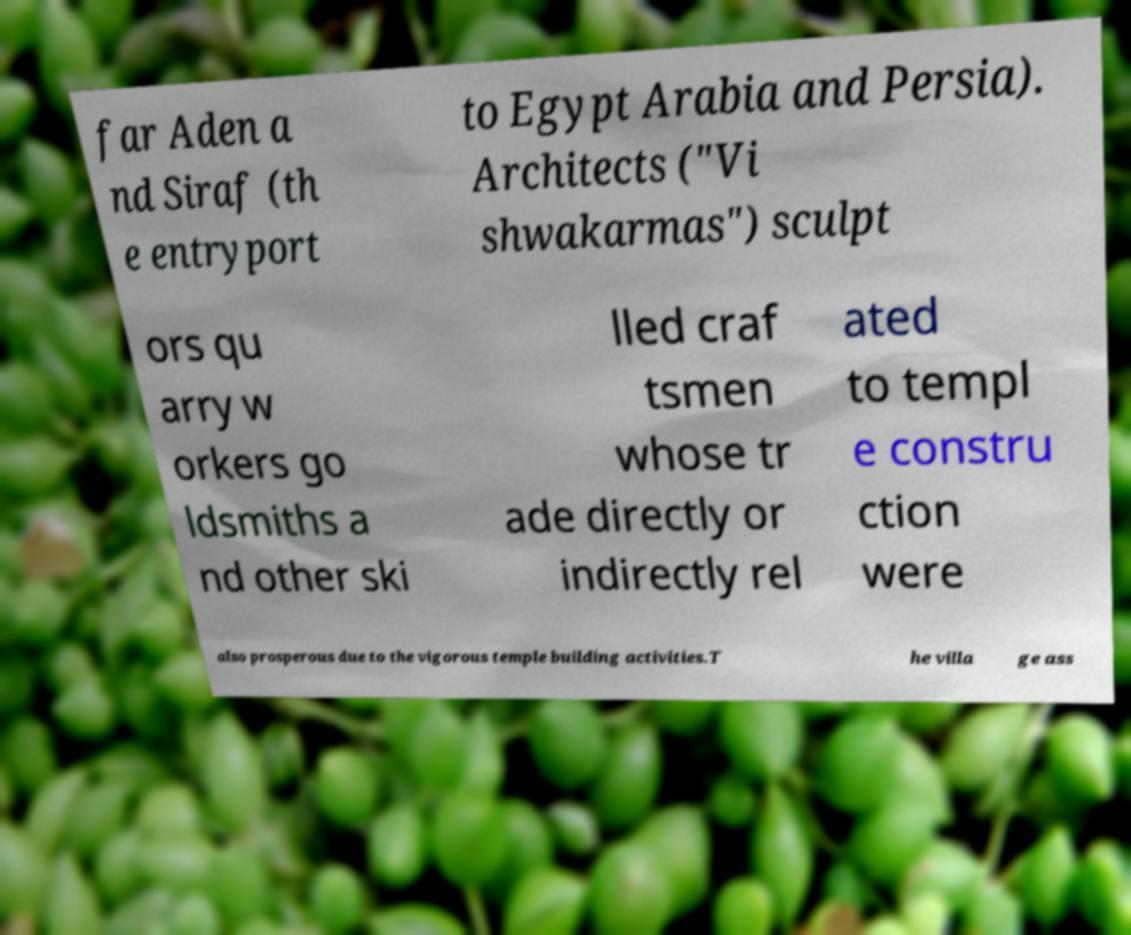Could you assist in decoding the text presented in this image and type it out clearly? far Aden a nd Siraf (th e entryport to Egypt Arabia and Persia). Architects ("Vi shwakarmas") sculpt ors qu arry w orkers go ldsmiths a nd other ski lled craf tsmen whose tr ade directly or indirectly rel ated to templ e constru ction were also prosperous due to the vigorous temple building activities.T he villa ge ass 